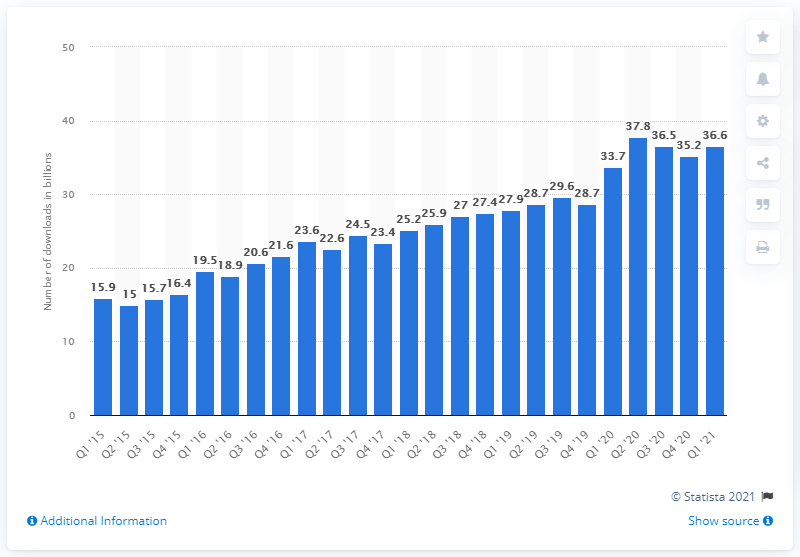Highlight a few significant elements in this photo. During the period from the first quarter of 2015 to the first quarter of 2021, the estimated total combined downloads of apps from the Apple App Store and Google Play were approximately 36.6 billion. 